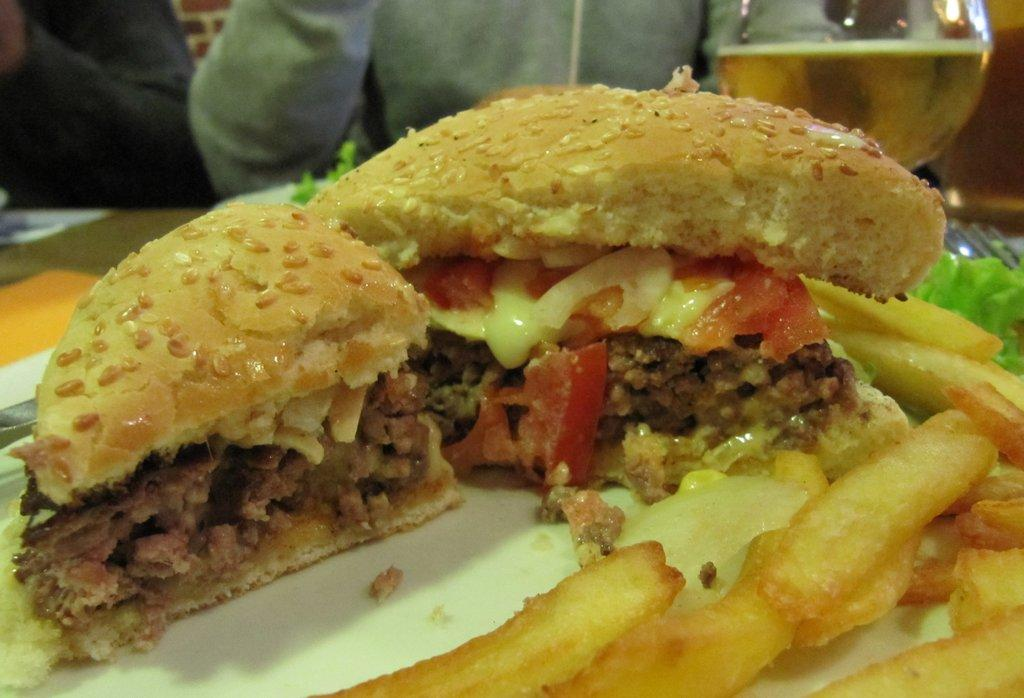What types of items can be seen in the image? There are food items and a glass with a drink in the image. Where are these items located? The food items and glass are on a table. Are there any people present in the image? Yes, there are two persons near the table. Can you see a toad attempting to enter the house in the image? There is no toad or house present in the image. 